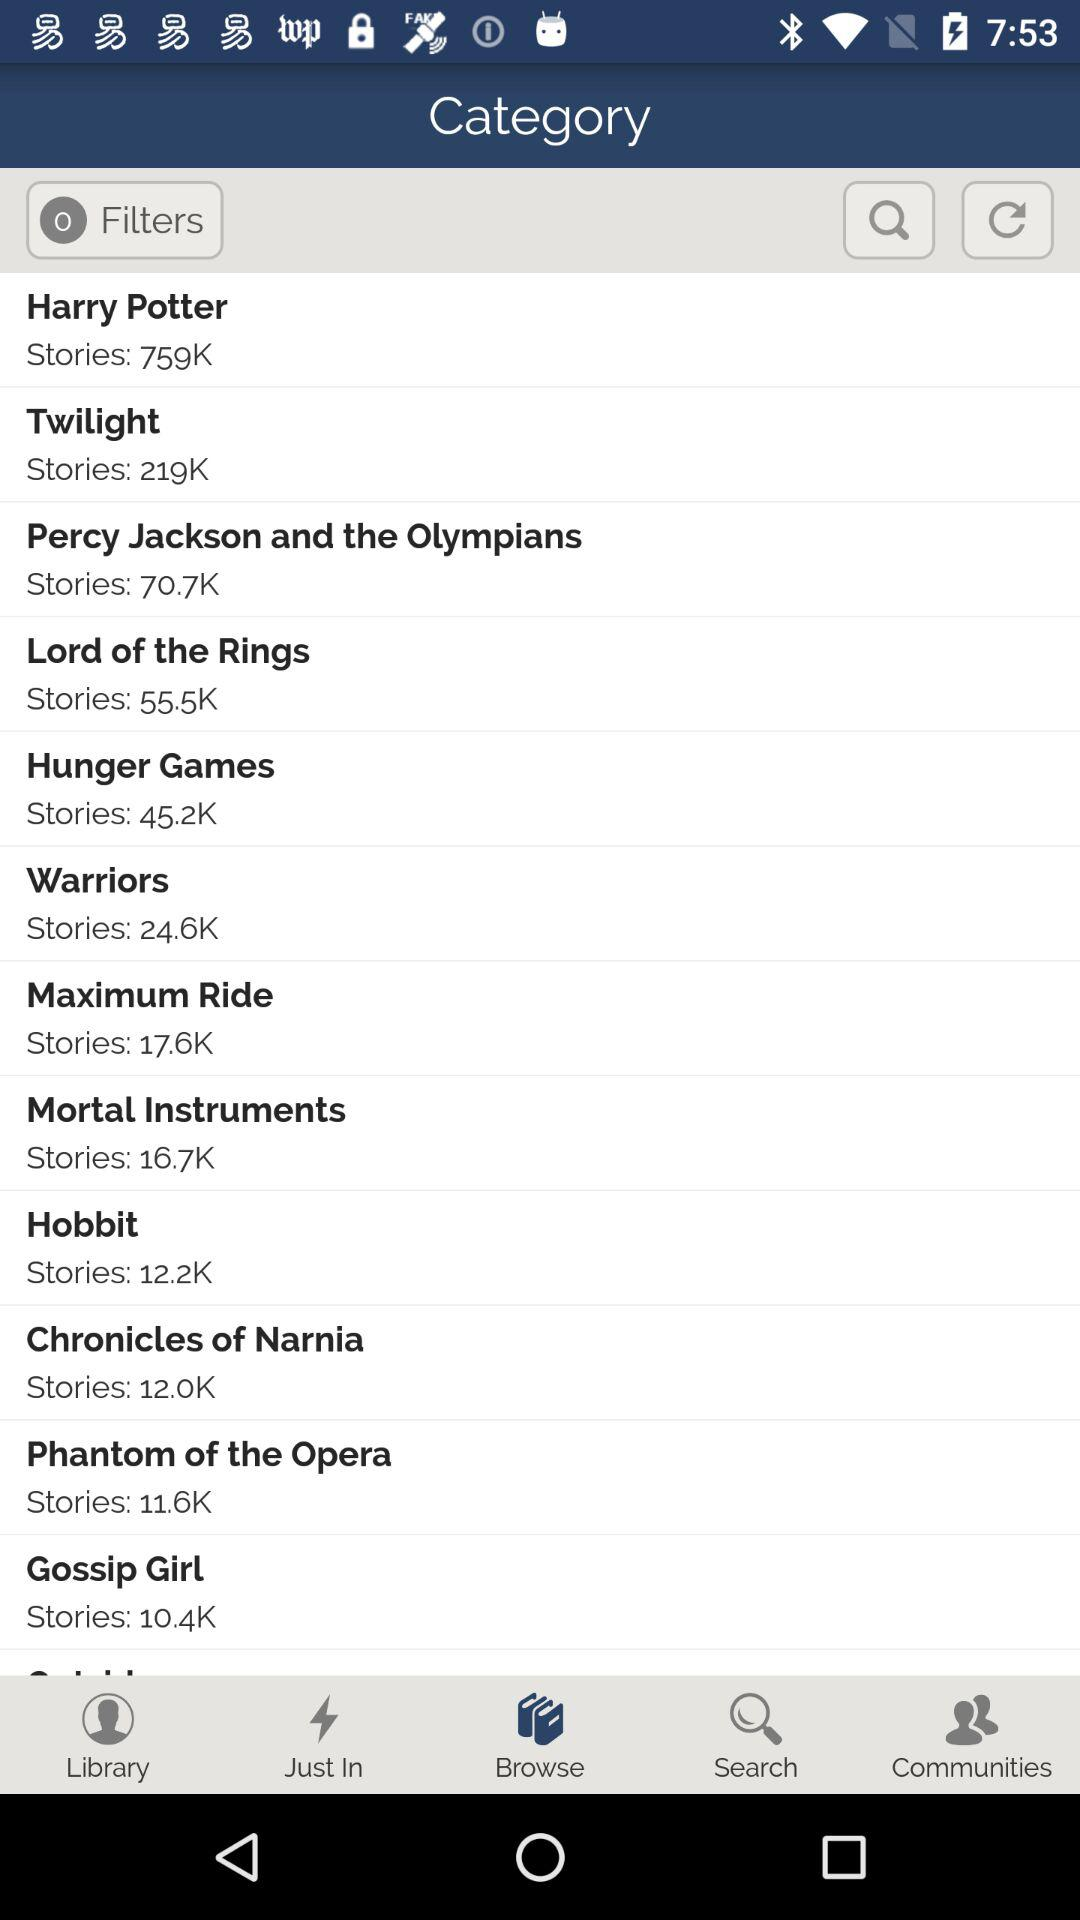How many stories are there in "Harry Potter"? There are 759,000 stories. 